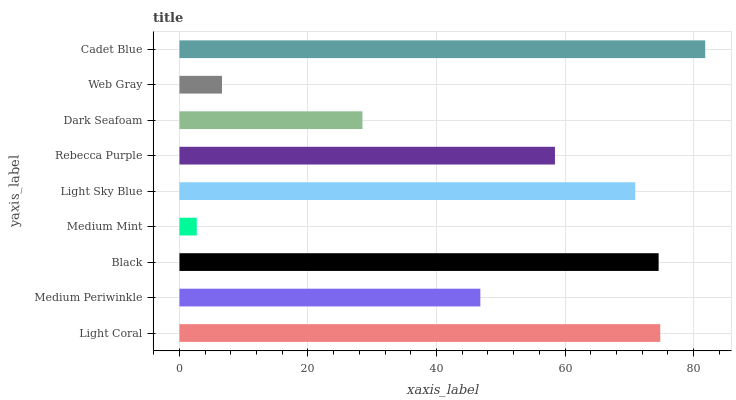Is Medium Mint the minimum?
Answer yes or no. Yes. Is Cadet Blue the maximum?
Answer yes or no. Yes. Is Medium Periwinkle the minimum?
Answer yes or no. No. Is Medium Periwinkle the maximum?
Answer yes or no. No. Is Light Coral greater than Medium Periwinkle?
Answer yes or no. Yes. Is Medium Periwinkle less than Light Coral?
Answer yes or no. Yes. Is Medium Periwinkle greater than Light Coral?
Answer yes or no. No. Is Light Coral less than Medium Periwinkle?
Answer yes or no. No. Is Rebecca Purple the high median?
Answer yes or no. Yes. Is Rebecca Purple the low median?
Answer yes or no. Yes. Is Dark Seafoam the high median?
Answer yes or no. No. Is Web Gray the low median?
Answer yes or no. No. 